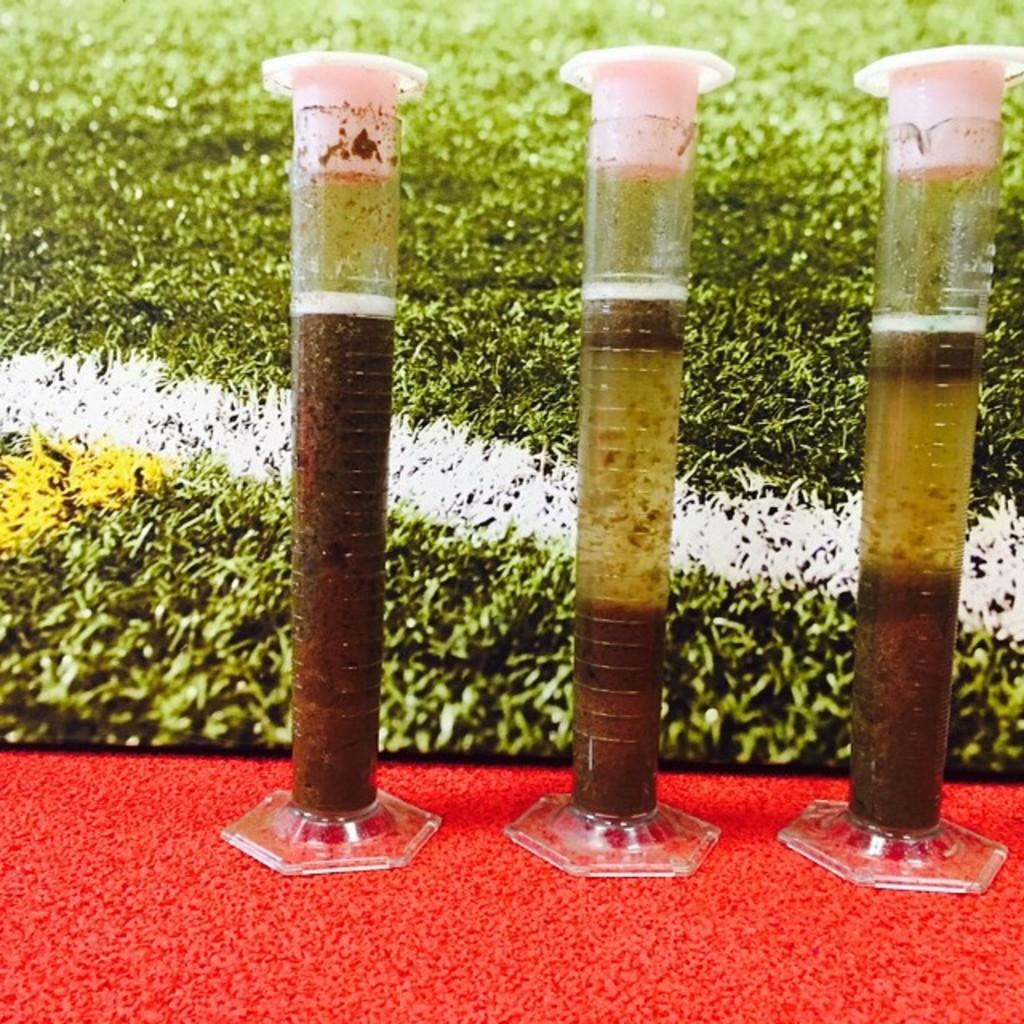What type of containers are present in the image? There are test tubes with liquid in the image in the image. What is the color of the ground in the image? The ground is red in color. What type of vegetation can be seen in the background of the image? There is grass visible in the background of the image. What type of milk is being poured into the test tubes in the image? There is no milk present in the image; the test tubes contain liquid. 